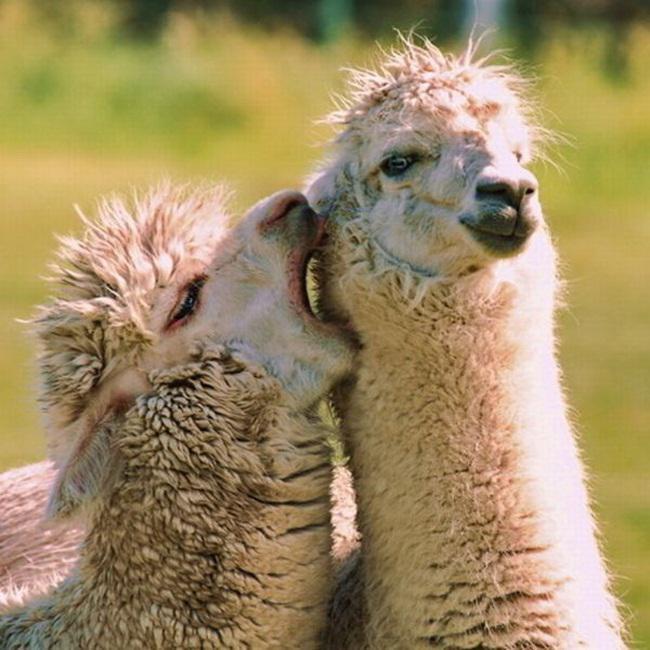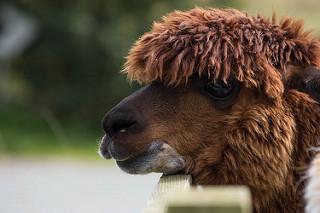The first image is the image on the left, the second image is the image on the right. Examine the images to the left and right. Is the description "The left and right image contains a total of four llamas." accurate? Answer yes or no. No. The first image is the image on the left, the second image is the image on the right. Given the left and right images, does the statement "An image shows two llamas, with the mouth of the one on the left touching the face of the one on the right." hold true? Answer yes or no. Yes. 